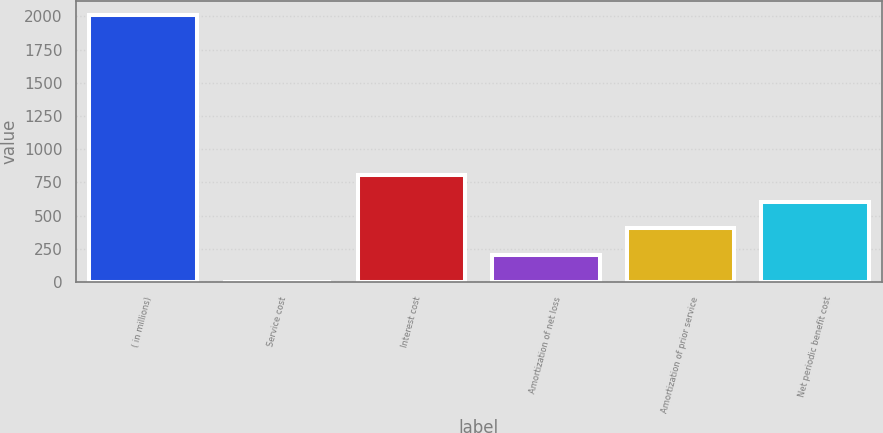Convert chart. <chart><loc_0><loc_0><loc_500><loc_500><bar_chart><fcel>( in millions)<fcel>Service cost<fcel>Interest cost<fcel>Amortization of net loss<fcel>Amortization of prior service<fcel>Net periodic benefit cost<nl><fcel>2014<fcel>1.1<fcel>806.26<fcel>202.39<fcel>403.68<fcel>604.97<nl></chart> 